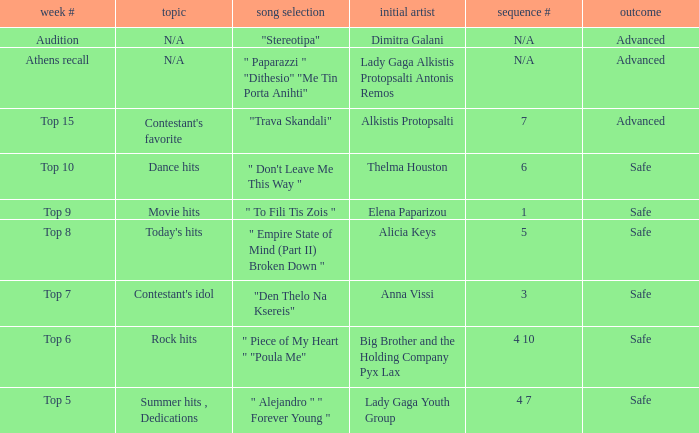Which week had the song choice " empire state of mind (part ii) broken down "? Top 8. 